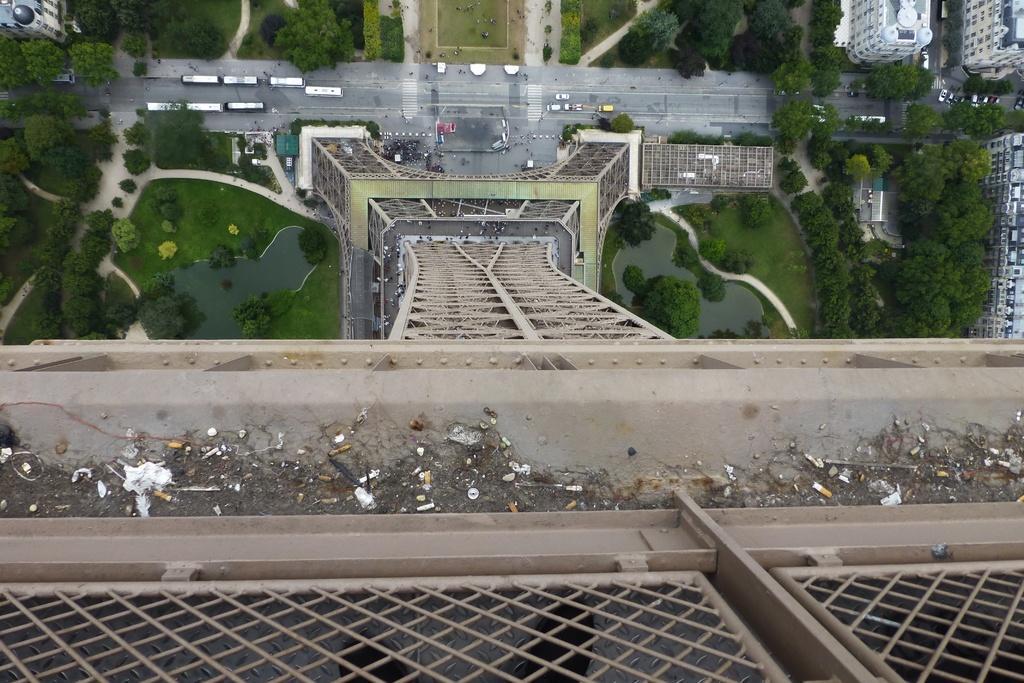Describe this image in one or two sentences. This is the bottom view from the top of the eiffel tower. In this image we can see the road, vehicles, trees, grass, buildings and other objects. At the bottom of the image there is the fence, iron texture and other objects. 